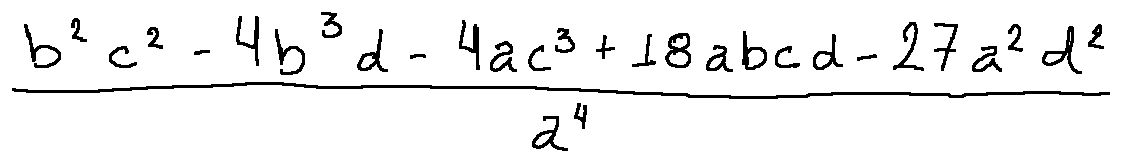Convert formula to latex. <formula><loc_0><loc_0><loc_500><loc_500>\frac { b ^ { 2 } c ^ { 2 } - 4 b ^ { 3 } d - 4 a c ^ { 3 } + 1 8 a b c d - 2 7 a ^ { 2 } d ^ { 2 } } { a ^ { 4 } }</formula> 